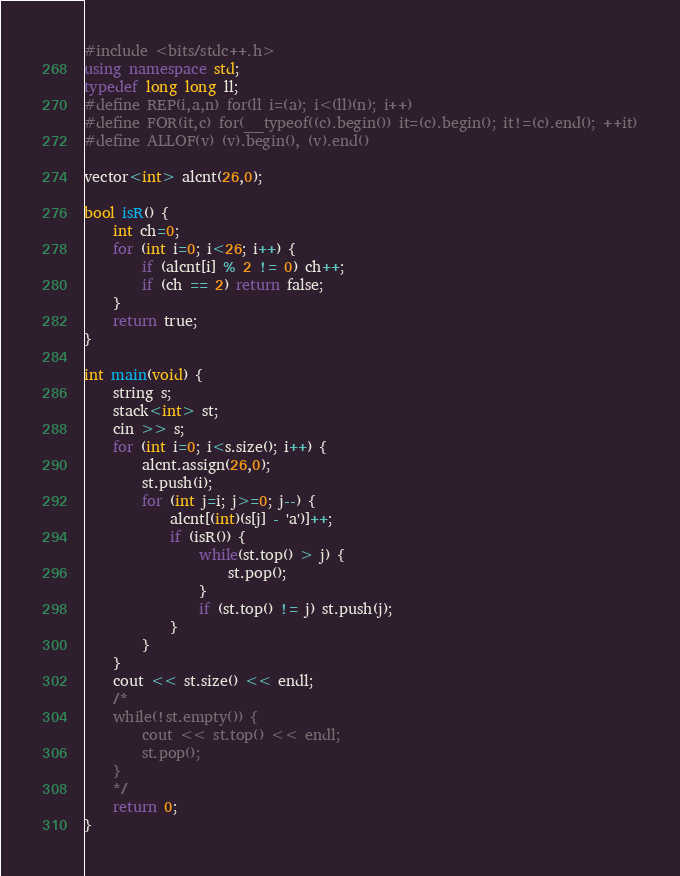Convert code to text. <code><loc_0><loc_0><loc_500><loc_500><_C++_>#include <bits/stdc++.h>
using namespace std;
typedef long long ll;
#define REP(i,a,n) for(ll i=(a); i<(ll)(n); i++)
#define FOR(it,c) for(__typeof((c).begin()) it=(c).begin(); it!=(c).end(); ++it)
#define ALLOF(v) (v).begin(), (v).end()

vector<int> alcnt(26,0);

bool isR() {
    int ch=0;
    for (int i=0; i<26; i++) {
        if (alcnt[i] % 2 != 0) ch++;
        if (ch == 2) return false;
    }
    return true;
}

int main(void) {
    string s;
    stack<int> st;
    cin >> s;
    for (int i=0; i<s.size(); i++) {
        alcnt.assign(26,0);
        st.push(i);
        for (int j=i; j>=0; j--) {
            alcnt[(int)(s[j] - 'a')]++;
            if (isR()) {
                while(st.top() > j) {
                    st.pop();
                }
                if (st.top() != j) st.push(j);
            }
        }
    }
    cout << st.size() << endl;
    /*
    while(!st.empty()) {
        cout << st.top() << endl;
        st.pop();
    }
    */
    return 0;
}
</code> 